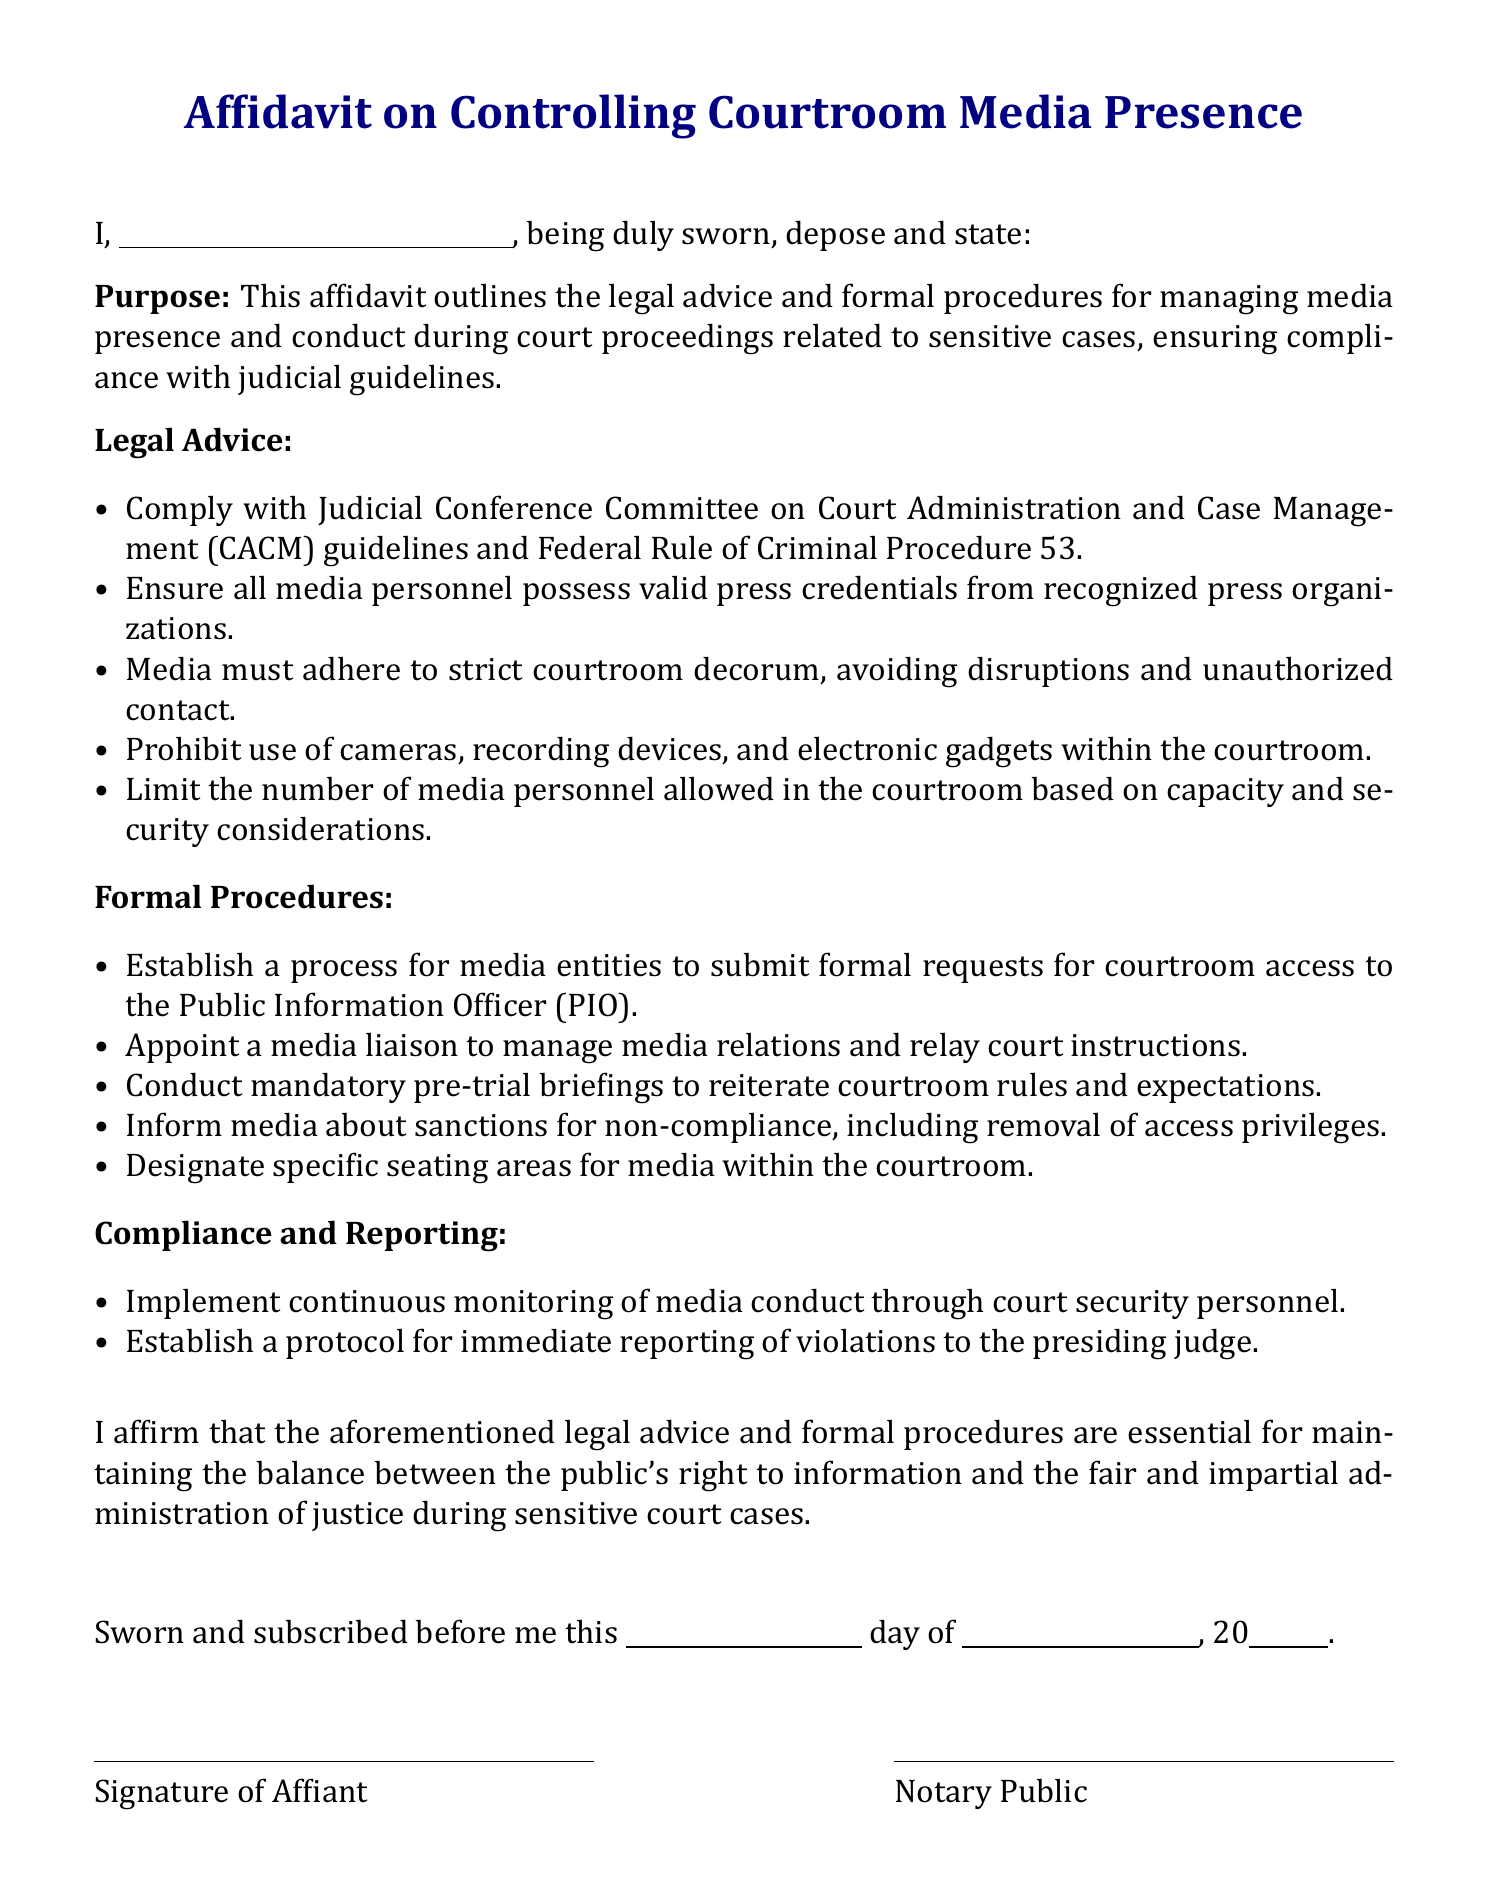What is the purpose of the affidavit? The affidavit outlines the legal advice and formal procedures for managing media presence and conduct during court proceedings related to sensitive cases.
Answer: Managing media presence Who must possess valid press credentials? All media personnel must possess valid press credentials from recognized press organizations.
Answer: Media personnel What is prohibited inside the courtroom? The document states that the use of cameras, recording devices, and electronic gadgets within the courtroom is prohibited.
Answer: Cameras and recording devices What must media entities do to gain courtroom access? Media entities must submit formal requests for courtroom access to the Public Information Officer.
Answer: Submit requests What is the role of the media liaison? The media liaison is responsible for managing media relations and relaying court instructions.
Answer: Manage media relations What happens if media personnel violate courtroom rules? The document details that there are sanctions for non-compliance, which include removal of access privileges.
Answer: Removal of access privileges How often should monitoring of media conduct occur? Continuous monitoring of media conduct should be implemented through court security personnel.
Answer: Continuous monitoring When must mandatory pre-trial briefings occur? Mandatory pre-trial briefings are conducted to reiterate courtroom rules and expectations before trial.
Answer: Before trial What is required to be sworn before a notary public? The affiant must affirm the aforementioned legal advice and formal procedures regarding courtroom media presence.
Answer: Legal advice affirmation 